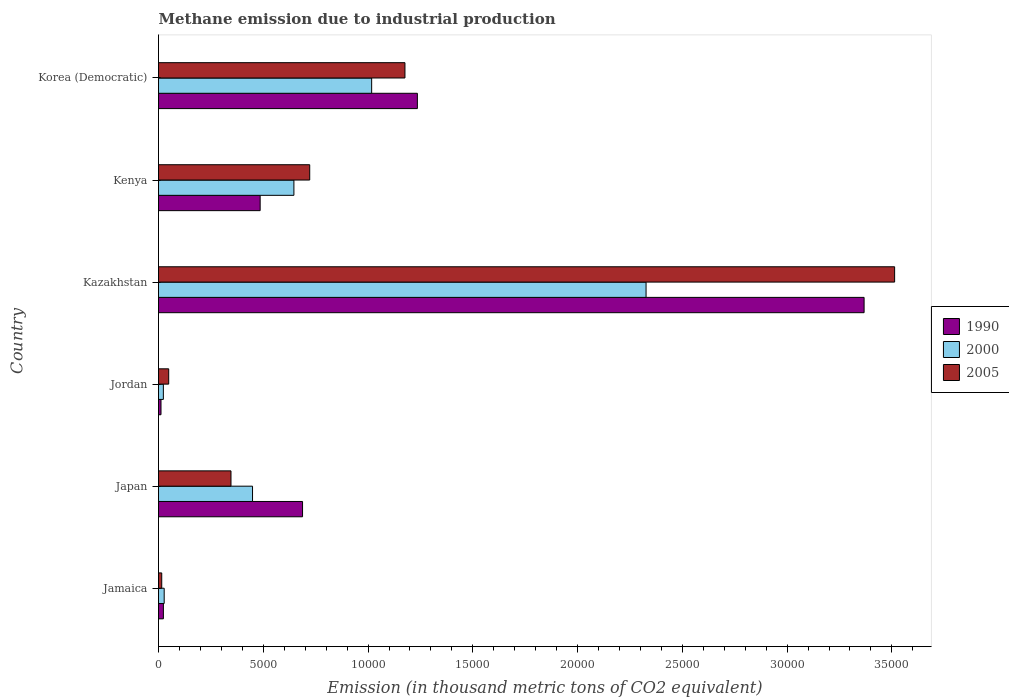How many different coloured bars are there?
Keep it short and to the point. 3. How many groups of bars are there?
Offer a very short reply. 6. Are the number of bars per tick equal to the number of legend labels?
Ensure brevity in your answer.  Yes. How many bars are there on the 3rd tick from the top?
Make the answer very short. 3. What is the label of the 4th group of bars from the top?
Provide a short and direct response. Jordan. What is the amount of methane emitted in 2005 in Kazakhstan?
Offer a very short reply. 3.51e+04. Across all countries, what is the maximum amount of methane emitted in 2005?
Make the answer very short. 3.51e+04. Across all countries, what is the minimum amount of methane emitted in 2000?
Give a very brief answer. 231.4. In which country was the amount of methane emitted in 2000 maximum?
Your answer should be compact. Kazakhstan. In which country was the amount of methane emitted in 1990 minimum?
Offer a terse response. Jordan. What is the total amount of methane emitted in 2005 in the graph?
Offer a terse response. 5.82e+04. What is the difference between the amount of methane emitted in 1990 in Jordan and that in Korea (Democratic)?
Provide a short and direct response. -1.22e+04. What is the difference between the amount of methane emitted in 2005 in Jordan and the amount of methane emitted in 2000 in Kenya?
Ensure brevity in your answer.  -5975.1. What is the average amount of methane emitted in 2000 per country?
Give a very brief answer. 7481.55. What is the difference between the amount of methane emitted in 2005 and amount of methane emitted in 2000 in Korea (Democratic)?
Your answer should be compact. 1589.4. In how many countries, is the amount of methane emitted in 2005 greater than 17000 thousand metric tons?
Offer a terse response. 1. What is the ratio of the amount of methane emitted in 2005 in Jamaica to that in Japan?
Provide a short and direct response. 0.04. Is the amount of methane emitted in 1990 in Japan less than that in Jordan?
Provide a succinct answer. No. Is the difference between the amount of methane emitted in 2005 in Kenya and Korea (Democratic) greater than the difference between the amount of methane emitted in 2000 in Kenya and Korea (Democratic)?
Offer a very short reply. No. What is the difference between the highest and the second highest amount of methane emitted in 1990?
Ensure brevity in your answer.  2.13e+04. What is the difference between the highest and the lowest amount of methane emitted in 2005?
Provide a short and direct response. 3.50e+04. What does the 1st bar from the top in Kazakhstan represents?
Keep it short and to the point. 2005. Is it the case that in every country, the sum of the amount of methane emitted in 2000 and amount of methane emitted in 1990 is greater than the amount of methane emitted in 2005?
Give a very brief answer. No. Are all the bars in the graph horizontal?
Offer a very short reply. Yes. What is the difference between two consecutive major ticks on the X-axis?
Make the answer very short. 5000. Are the values on the major ticks of X-axis written in scientific E-notation?
Offer a very short reply. No. Does the graph contain any zero values?
Provide a short and direct response. No. Where does the legend appear in the graph?
Make the answer very short. Center right. How many legend labels are there?
Your response must be concise. 3. What is the title of the graph?
Keep it short and to the point. Methane emission due to industrial production. What is the label or title of the X-axis?
Your response must be concise. Emission (in thousand metric tons of CO2 equivalent). What is the Emission (in thousand metric tons of CO2 equivalent) of 1990 in Jamaica?
Provide a short and direct response. 232.7. What is the Emission (in thousand metric tons of CO2 equivalent) in 2000 in Jamaica?
Offer a terse response. 270.4. What is the Emission (in thousand metric tons of CO2 equivalent) of 2005 in Jamaica?
Your response must be concise. 153.3. What is the Emission (in thousand metric tons of CO2 equivalent) of 1990 in Japan?
Your answer should be very brief. 6873.6. What is the Emission (in thousand metric tons of CO2 equivalent) in 2000 in Japan?
Provide a succinct answer. 4486.9. What is the Emission (in thousand metric tons of CO2 equivalent) of 2005 in Japan?
Keep it short and to the point. 3458.3. What is the Emission (in thousand metric tons of CO2 equivalent) in 1990 in Jordan?
Give a very brief answer. 118.4. What is the Emission (in thousand metric tons of CO2 equivalent) of 2000 in Jordan?
Your answer should be compact. 231.4. What is the Emission (in thousand metric tons of CO2 equivalent) in 2005 in Jordan?
Offer a terse response. 486.3. What is the Emission (in thousand metric tons of CO2 equivalent) in 1990 in Kazakhstan?
Provide a succinct answer. 3.37e+04. What is the Emission (in thousand metric tons of CO2 equivalent) in 2000 in Kazakhstan?
Your response must be concise. 2.33e+04. What is the Emission (in thousand metric tons of CO2 equivalent) of 2005 in Kazakhstan?
Provide a succinct answer. 3.51e+04. What is the Emission (in thousand metric tons of CO2 equivalent) in 1990 in Kenya?
Your answer should be compact. 4850.8. What is the Emission (in thousand metric tons of CO2 equivalent) of 2000 in Kenya?
Make the answer very short. 6461.4. What is the Emission (in thousand metric tons of CO2 equivalent) of 2005 in Kenya?
Your answer should be compact. 7215.9. What is the Emission (in thousand metric tons of CO2 equivalent) of 1990 in Korea (Democratic)?
Keep it short and to the point. 1.24e+04. What is the Emission (in thousand metric tons of CO2 equivalent) of 2000 in Korea (Democratic)?
Your answer should be compact. 1.02e+04. What is the Emission (in thousand metric tons of CO2 equivalent) of 2005 in Korea (Democratic)?
Give a very brief answer. 1.18e+04. Across all countries, what is the maximum Emission (in thousand metric tons of CO2 equivalent) of 1990?
Offer a terse response. 3.37e+04. Across all countries, what is the maximum Emission (in thousand metric tons of CO2 equivalent) of 2000?
Make the answer very short. 2.33e+04. Across all countries, what is the maximum Emission (in thousand metric tons of CO2 equivalent) in 2005?
Provide a succinct answer. 3.51e+04. Across all countries, what is the minimum Emission (in thousand metric tons of CO2 equivalent) of 1990?
Provide a short and direct response. 118.4. Across all countries, what is the minimum Emission (in thousand metric tons of CO2 equivalent) in 2000?
Give a very brief answer. 231.4. Across all countries, what is the minimum Emission (in thousand metric tons of CO2 equivalent) of 2005?
Keep it short and to the point. 153.3. What is the total Emission (in thousand metric tons of CO2 equivalent) in 1990 in the graph?
Your answer should be compact. 5.81e+04. What is the total Emission (in thousand metric tons of CO2 equivalent) in 2000 in the graph?
Your response must be concise. 4.49e+04. What is the total Emission (in thousand metric tons of CO2 equivalent) of 2005 in the graph?
Provide a short and direct response. 5.82e+04. What is the difference between the Emission (in thousand metric tons of CO2 equivalent) in 1990 in Jamaica and that in Japan?
Ensure brevity in your answer.  -6640.9. What is the difference between the Emission (in thousand metric tons of CO2 equivalent) in 2000 in Jamaica and that in Japan?
Your answer should be compact. -4216.5. What is the difference between the Emission (in thousand metric tons of CO2 equivalent) of 2005 in Jamaica and that in Japan?
Your answer should be compact. -3305. What is the difference between the Emission (in thousand metric tons of CO2 equivalent) of 1990 in Jamaica and that in Jordan?
Your answer should be compact. 114.3. What is the difference between the Emission (in thousand metric tons of CO2 equivalent) of 2000 in Jamaica and that in Jordan?
Your response must be concise. 39. What is the difference between the Emission (in thousand metric tons of CO2 equivalent) of 2005 in Jamaica and that in Jordan?
Offer a very short reply. -333. What is the difference between the Emission (in thousand metric tons of CO2 equivalent) in 1990 in Jamaica and that in Kazakhstan?
Provide a succinct answer. -3.34e+04. What is the difference between the Emission (in thousand metric tons of CO2 equivalent) in 2000 in Jamaica and that in Kazakhstan?
Give a very brief answer. -2.30e+04. What is the difference between the Emission (in thousand metric tons of CO2 equivalent) in 2005 in Jamaica and that in Kazakhstan?
Provide a succinct answer. -3.50e+04. What is the difference between the Emission (in thousand metric tons of CO2 equivalent) in 1990 in Jamaica and that in Kenya?
Give a very brief answer. -4618.1. What is the difference between the Emission (in thousand metric tons of CO2 equivalent) of 2000 in Jamaica and that in Kenya?
Give a very brief answer. -6191. What is the difference between the Emission (in thousand metric tons of CO2 equivalent) in 2005 in Jamaica and that in Kenya?
Ensure brevity in your answer.  -7062.6. What is the difference between the Emission (in thousand metric tons of CO2 equivalent) in 1990 in Jamaica and that in Korea (Democratic)?
Offer a very short reply. -1.21e+04. What is the difference between the Emission (in thousand metric tons of CO2 equivalent) in 2000 in Jamaica and that in Korea (Democratic)?
Provide a succinct answer. -9901.2. What is the difference between the Emission (in thousand metric tons of CO2 equivalent) in 2005 in Jamaica and that in Korea (Democratic)?
Your answer should be very brief. -1.16e+04. What is the difference between the Emission (in thousand metric tons of CO2 equivalent) in 1990 in Japan and that in Jordan?
Keep it short and to the point. 6755.2. What is the difference between the Emission (in thousand metric tons of CO2 equivalent) in 2000 in Japan and that in Jordan?
Keep it short and to the point. 4255.5. What is the difference between the Emission (in thousand metric tons of CO2 equivalent) of 2005 in Japan and that in Jordan?
Offer a very short reply. 2972. What is the difference between the Emission (in thousand metric tons of CO2 equivalent) in 1990 in Japan and that in Kazakhstan?
Your response must be concise. -2.68e+04. What is the difference between the Emission (in thousand metric tons of CO2 equivalent) in 2000 in Japan and that in Kazakhstan?
Make the answer very short. -1.88e+04. What is the difference between the Emission (in thousand metric tons of CO2 equivalent) of 2005 in Japan and that in Kazakhstan?
Your answer should be very brief. -3.17e+04. What is the difference between the Emission (in thousand metric tons of CO2 equivalent) of 1990 in Japan and that in Kenya?
Keep it short and to the point. 2022.8. What is the difference between the Emission (in thousand metric tons of CO2 equivalent) in 2000 in Japan and that in Kenya?
Ensure brevity in your answer.  -1974.5. What is the difference between the Emission (in thousand metric tons of CO2 equivalent) in 2005 in Japan and that in Kenya?
Give a very brief answer. -3757.6. What is the difference between the Emission (in thousand metric tons of CO2 equivalent) of 1990 in Japan and that in Korea (Democratic)?
Provide a succinct answer. -5480.1. What is the difference between the Emission (in thousand metric tons of CO2 equivalent) in 2000 in Japan and that in Korea (Democratic)?
Provide a short and direct response. -5684.7. What is the difference between the Emission (in thousand metric tons of CO2 equivalent) of 2005 in Japan and that in Korea (Democratic)?
Ensure brevity in your answer.  -8302.7. What is the difference between the Emission (in thousand metric tons of CO2 equivalent) in 1990 in Jordan and that in Kazakhstan?
Offer a very short reply. -3.36e+04. What is the difference between the Emission (in thousand metric tons of CO2 equivalent) of 2000 in Jordan and that in Kazakhstan?
Ensure brevity in your answer.  -2.30e+04. What is the difference between the Emission (in thousand metric tons of CO2 equivalent) of 2005 in Jordan and that in Kazakhstan?
Keep it short and to the point. -3.46e+04. What is the difference between the Emission (in thousand metric tons of CO2 equivalent) of 1990 in Jordan and that in Kenya?
Keep it short and to the point. -4732.4. What is the difference between the Emission (in thousand metric tons of CO2 equivalent) of 2000 in Jordan and that in Kenya?
Keep it short and to the point. -6230. What is the difference between the Emission (in thousand metric tons of CO2 equivalent) of 2005 in Jordan and that in Kenya?
Offer a terse response. -6729.6. What is the difference between the Emission (in thousand metric tons of CO2 equivalent) of 1990 in Jordan and that in Korea (Democratic)?
Offer a terse response. -1.22e+04. What is the difference between the Emission (in thousand metric tons of CO2 equivalent) of 2000 in Jordan and that in Korea (Democratic)?
Your answer should be very brief. -9940.2. What is the difference between the Emission (in thousand metric tons of CO2 equivalent) of 2005 in Jordan and that in Korea (Democratic)?
Your response must be concise. -1.13e+04. What is the difference between the Emission (in thousand metric tons of CO2 equivalent) in 1990 in Kazakhstan and that in Kenya?
Provide a short and direct response. 2.88e+04. What is the difference between the Emission (in thousand metric tons of CO2 equivalent) in 2000 in Kazakhstan and that in Kenya?
Offer a terse response. 1.68e+04. What is the difference between the Emission (in thousand metric tons of CO2 equivalent) in 2005 in Kazakhstan and that in Kenya?
Give a very brief answer. 2.79e+04. What is the difference between the Emission (in thousand metric tons of CO2 equivalent) of 1990 in Kazakhstan and that in Korea (Democratic)?
Keep it short and to the point. 2.13e+04. What is the difference between the Emission (in thousand metric tons of CO2 equivalent) of 2000 in Kazakhstan and that in Korea (Democratic)?
Give a very brief answer. 1.31e+04. What is the difference between the Emission (in thousand metric tons of CO2 equivalent) in 2005 in Kazakhstan and that in Korea (Democratic)?
Keep it short and to the point. 2.34e+04. What is the difference between the Emission (in thousand metric tons of CO2 equivalent) in 1990 in Kenya and that in Korea (Democratic)?
Ensure brevity in your answer.  -7502.9. What is the difference between the Emission (in thousand metric tons of CO2 equivalent) in 2000 in Kenya and that in Korea (Democratic)?
Offer a very short reply. -3710.2. What is the difference between the Emission (in thousand metric tons of CO2 equivalent) in 2005 in Kenya and that in Korea (Democratic)?
Your answer should be compact. -4545.1. What is the difference between the Emission (in thousand metric tons of CO2 equivalent) in 1990 in Jamaica and the Emission (in thousand metric tons of CO2 equivalent) in 2000 in Japan?
Provide a short and direct response. -4254.2. What is the difference between the Emission (in thousand metric tons of CO2 equivalent) of 1990 in Jamaica and the Emission (in thousand metric tons of CO2 equivalent) of 2005 in Japan?
Ensure brevity in your answer.  -3225.6. What is the difference between the Emission (in thousand metric tons of CO2 equivalent) in 2000 in Jamaica and the Emission (in thousand metric tons of CO2 equivalent) in 2005 in Japan?
Provide a short and direct response. -3187.9. What is the difference between the Emission (in thousand metric tons of CO2 equivalent) in 1990 in Jamaica and the Emission (in thousand metric tons of CO2 equivalent) in 2000 in Jordan?
Your answer should be compact. 1.3. What is the difference between the Emission (in thousand metric tons of CO2 equivalent) of 1990 in Jamaica and the Emission (in thousand metric tons of CO2 equivalent) of 2005 in Jordan?
Offer a terse response. -253.6. What is the difference between the Emission (in thousand metric tons of CO2 equivalent) in 2000 in Jamaica and the Emission (in thousand metric tons of CO2 equivalent) in 2005 in Jordan?
Provide a succinct answer. -215.9. What is the difference between the Emission (in thousand metric tons of CO2 equivalent) of 1990 in Jamaica and the Emission (in thousand metric tons of CO2 equivalent) of 2000 in Kazakhstan?
Make the answer very short. -2.30e+04. What is the difference between the Emission (in thousand metric tons of CO2 equivalent) in 1990 in Jamaica and the Emission (in thousand metric tons of CO2 equivalent) in 2005 in Kazakhstan?
Your answer should be compact. -3.49e+04. What is the difference between the Emission (in thousand metric tons of CO2 equivalent) of 2000 in Jamaica and the Emission (in thousand metric tons of CO2 equivalent) of 2005 in Kazakhstan?
Your answer should be compact. -3.49e+04. What is the difference between the Emission (in thousand metric tons of CO2 equivalent) of 1990 in Jamaica and the Emission (in thousand metric tons of CO2 equivalent) of 2000 in Kenya?
Make the answer very short. -6228.7. What is the difference between the Emission (in thousand metric tons of CO2 equivalent) in 1990 in Jamaica and the Emission (in thousand metric tons of CO2 equivalent) in 2005 in Kenya?
Your answer should be compact. -6983.2. What is the difference between the Emission (in thousand metric tons of CO2 equivalent) in 2000 in Jamaica and the Emission (in thousand metric tons of CO2 equivalent) in 2005 in Kenya?
Provide a succinct answer. -6945.5. What is the difference between the Emission (in thousand metric tons of CO2 equivalent) of 1990 in Jamaica and the Emission (in thousand metric tons of CO2 equivalent) of 2000 in Korea (Democratic)?
Give a very brief answer. -9938.9. What is the difference between the Emission (in thousand metric tons of CO2 equivalent) of 1990 in Jamaica and the Emission (in thousand metric tons of CO2 equivalent) of 2005 in Korea (Democratic)?
Keep it short and to the point. -1.15e+04. What is the difference between the Emission (in thousand metric tons of CO2 equivalent) in 2000 in Jamaica and the Emission (in thousand metric tons of CO2 equivalent) in 2005 in Korea (Democratic)?
Ensure brevity in your answer.  -1.15e+04. What is the difference between the Emission (in thousand metric tons of CO2 equivalent) of 1990 in Japan and the Emission (in thousand metric tons of CO2 equivalent) of 2000 in Jordan?
Provide a succinct answer. 6642.2. What is the difference between the Emission (in thousand metric tons of CO2 equivalent) in 1990 in Japan and the Emission (in thousand metric tons of CO2 equivalent) in 2005 in Jordan?
Offer a terse response. 6387.3. What is the difference between the Emission (in thousand metric tons of CO2 equivalent) in 2000 in Japan and the Emission (in thousand metric tons of CO2 equivalent) in 2005 in Jordan?
Offer a terse response. 4000.6. What is the difference between the Emission (in thousand metric tons of CO2 equivalent) in 1990 in Japan and the Emission (in thousand metric tons of CO2 equivalent) in 2000 in Kazakhstan?
Your answer should be compact. -1.64e+04. What is the difference between the Emission (in thousand metric tons of CO2 equivalent) in 1990 in Japan and the Emission (in thousand metric tons of CO2 equivalent) in 2005 in Kazakhstan?
Make the answer very short. -2.83e+04. What is the difference between the Emission (in thousand metric tons of CO2 equivalent) in 2000 in Japan and the Emission (in thousand metric tons of CO2 equivalent) in 2005 in Kazakhstan?
Your answer should be compact. -3.06e+04. What is the difference between the Emission (in thousand metric tons of CO2 equivalent) in 1990 in Japan and the Emission (in thousand metric tons of CO2 equivalent) in 2000 in Kenya?
Ensure brevity in your answer.  412.2. What is the difference between the Emission (in thousand metric tons of CO2 equivalent) in 1990 in Japan and the Emission (in thousand metric tons of CO2 equivalent) in 2005 in Kenya?
Your response must be concise. -342.3. What is the difference between the Emission (in thousand metric tons of CO2 equivalent) in 2000 in Japan and the Emission (in thousand metric tons of CO2 equivalent) in 2005 in Kenya?
Give a very brief answer. -2729. What is the difference between the Emission (in thousand metric tons of CO2 equivalent) in 1990 in Japan and the Emission (in thousand metric tons of CO2 equivalent) in 2000 in Korea (Democratic)?
Offer a very short reply. -3298. What is the difference between the Emission (in thousand metric tons of CO2 equivalent) of 1990 in Japan and the Emission (in thousand metric tons of CO2 equivalent) of 2005 in Korea (Democratic)?
Offer a terse response. -4887.4. What is the difference between the Emission (in thousand metric tons of CO2 equivalent) of 2000 in Japan and the Emission (in thousand metric tons of CO2 equivalent) of 2005 in Korea (Democratic)?
Keep it short and to the point. -7274.1. What is the difference between the Emission (in thousand metric tons of CO2 equivalent) of 1990 in Jordan and the Emission (in thousand metric tons of CO2 equivalent) of 2000 in Kazakhstan?
Provide a short and direct response. -2.31e+04. What is the difference between the Emission (in thousand metric tons of CO2 equivalent) in 1990 in Jordan and the Emission (in thousand metric tons of CO2 equivalent) in 2005 in Kazakhstan?
Give a very brief answer. -3.50e+04. What is the difference between the Emission (in thousand metric tons of CO2 equivalent) in 2000 in Jordan and the Emission (in thousand metric tons of CO2 equivalent) in 2005 in Kazakhstan?
Your response must be concise. -3.49e+04. What is the difference between the Emission (in thousand metric tons of CO2 equivalent) of 1990 in Jordan and the Emission (in thousand metric tons of CO2 equivalent) of 2000 in Kenya?
Your answer should be very brief. -6343. What is the difference between the Emission (in thousand metric tons of CO2 equivalent) of 1990 in Jordan and the Emission (in thousand metric tons of CO2 equivalent) of 2005 in Kenya?
Keep it short and to the point. -7097.5. What is the difference between the Emission (in thousand metric tons of CO2 equivalent) of 2000 in Jordan and the Emission (in thousand metric tons of CO2 equivalent) of 2005 in Kenya?
Your answer should be compact. -6984.5. What is the difference between the Emission (in thousand metric tons of CO2 equivalent) of 1990 in Jordan and the Emission (in thousand metric tons of CO2 equivalent) of 2000 in Korea (Democratic)?
Keep it short and to the point. -1.01e+04. What is the difference between the Emission (in thousand metric tons of CO2 equivalent) in 1990 in Jordan and the Emission (in thousand metric tons of CO2 equivalent) in 2005 in Korea (Democratic)?
Give a very brief answer. -1.16e+04. What is the difference between the Emission (in thousand metric tons of CO2 equivalent) in 2000 in Jordan and the Emission (in thousand metric tons of CO2 equivalent) in 2005 in Korea (Democratic)?
Ensure brevity in your answer.  -1.15e+04. What is the difference between the Emission (in thousand metric tons of CO2 equivalent) in 1990 in Kazakhstan and the Emission (in thousand metric tons of CO2 equivalent) in 2000 in Kenya?
Give a very brief answer. 2.72e+04. What is the difference between the Emission (in thousand metric tons of CO2 equivalent) of 1990 in Kazakhstan and the Emission (in thousand metric tons of CO2 equivalent) of 2005 in Kenya?
Provide a succinct answer. 2.65e+04. What is the difference between the Emission (in thousand metric tons of CO2 equivalent) in 2000 in Kazakhstan and the Emission (in thousand metric tons of CO2 equivalent) in 2005 in Kenya?
Your answer should be very brief. 1.61e+04. What is the difference between the Emission (in thousand metric tons of CO2 equivalent) of 1990 in Kazakhstan and the Emission (in thousand metric tons of CO2 equivalent) of 2000 in Korea (Democratic)?
Your response must be concise. 2.35e+04. What is the difference between the Emission (in thousand metric tons of CO2 equivalent) in 1990 in Kazakhstan and the Emission (in thousand metric tons of CO2 equivalent) in 2005 in Korea (Democratic)?
Your answer should be very brief. 2.19e+04. What is the difference between the Emission (in thousand metric tons of CO2 equivalent) of 2000 in Kazakhstan and the Emission (in thousand metric tons of CO2 equivalent) of 2005 in Korea (Democratic)?
Your response must be concise. 1.15e+04. What is the difference between the Emission (in thousand metric tons of CO2 equivalent) of 1990 in Kenya and the Emission (in thousand metric tons of CO2 equivalent) of 2000 in Korea (Democratic)?
Your answer should be very brief. -5320.8. What is the difference between the Emission (in thousand metric tons of CO2 equivalent) of 1990 in Kenya and the Emission (in thousand metric tons of CO2 equivalent) of 2005 in Korea (Democratic)?
Provide a short and direct response. -6910.2. What is the difference between the Emission (in thousand metric tons of CO2 equivalent) in 2000 in Kenya and the Emission (in thousand metric tons of CO2 equivalent) in 2005 in Korea (Democratic)?
Keep it short and to the point. -5299.6. What is the average Emission (in thousand metric tons of CO2 equivalent) of 1990 per country?
Keep it short and to the point. 9683.75. What is the average Emission (in thousand metric tons of CO2 equivalent) in 2000 per country?
Offer a terse response. 7481.55. What is the average Emission (in thousand metric tons of CO2 equivalent) of 2005 per country?
Your answer should be compact. 9700.82. What is the difference between the Emission (in thousand metric tons of CO2 equivalent) of 1990 and Emission (in thousand metric tons of CO2 equivalent) of 2000 in Jamaica?
Offer a very short reply. -37.7. What is the difference between the Emission (in thousand metric tons of CO2 equivalent) in 1990 and Emission (in thousand metric tons of CO2 equivalent) in 2005 in Jamaica?
Give a very brief answer. 79.4. What is the difference between the Emission (in thousand metric tons of CO2 equivalent) in 2000 and Emission (in thousand metric tons of CO2 equivalent) in 2005 in Jamaica?
Your response must be concise. 117.1. What is the difference between the Emission (in thousand metric tons of CO2 equivalent) of 1990 and Emission (in thousand metric tons of CO2 equivalent) of 2000 in Japan?
Give a very brief answer. 2386.7. What is the difference between the Emission (in thousand metric tons of CO2 equivalent) of 1990 and Emission (in thousand metric tons of CO2 equivalent) of 2005 in Japan?
Give a very brief answer. 3415.3. What is the difference between the Emission (in thousand metric tons of CO2 equivalent) in 2000 and Emission (in thousand metric tons of CO2 equivalent) in 2005 in Japan?
Keep it short and to the point. 1028.6. What is the difference between the Emission (in thousand metric tons of CO2 equivalent) in 1990 and Emission (in thousand metric tons of CO2 equivalent) in 2000 in Jordan?
Your response must be concise. -113. What is the difference between the Emission (in thousand metric tons of CO2 equivalent) of 1990 and Emission (in thousand metric tons of CO2 equivalent) of 2005 in Jordan?
Give a very brief answer. -367.9. What is the difference between the Emission (in thousand metric tons of CO2 equivalent) in 2000 and Emission (in thousand metric tons of CO2 equivalent) in 2005 in Jordan?
Provide a succinct answer. -254.9. What is the difference between the Emission (in thousand metric tons of CO2 equivalent) of 1990 and Emission (in thousand metric tons of CO2 equivalent) of 2000 in Kazakhstan?
Ensure brevity in your answer.  1.04e+04. What is the difference between the Emission (in thousand metric tons of CO2 equivalent) of 1990 and Emission (in thousand metric tons of CO2 equivalent) of 2005 in Kazakhstan?
Provide a succinct answer. -1456.8. What is the difference between the Emission (in thousand metric tons of CO2 equivalent) in 2000 and Emission (in thousand metric tons of CO2 equivalent) in 2005 in Kazakhstan?
Provide a succinct answer. -1.19e+04. What is the difference between the Emission (in thousand metric tons of CO2 equivalent) in 1990 and Emission (in thousand metric tons of CO2 equivalent) in 2000 in Kenya?
Provide a short and direct response. -1610.6. What is the difference between the Emission (in thousand metric tons of CO2 equivalent) in 1990 and Emission (in thousand metric tons of CO2 equivalent) in 2005 in Kenya?
Your answer should be compact. -2365.1. What is the difference between the Emission (in thousand metric tons of CO2 equivalent) of 2000 and Emission (in thousand metric tons of CO2 equivalent) of 2005 in Kenya?
Your response must be concise. -754.5. What is the difference between the Emission (in thousand metric tons of CO2 equivalent) in 1990 and Emission (in thousand metric tons of CO2 equivalent) in 2000 in Korea (Democratic)?
Your response must be concise. 2182.1. What is the difference between the Emission (in thousand metric tons of CO2 equivalent) of 1990 and Emission (in thousand metric tons of CO2 equivalent) of 2005 in Korea (Democratic)?
Your answer should be very brief. 592.7. What is the difference between the Emission (in thousand metric tons of CO2 equivalent) of 2000 and Emission (in thousand metric tons of CO2 equivalent) of 2005 in Korea (Democratic)?
Make the answer very short. -1589.4. What is the ratio of the Emission (in thousand metric tons of CO2 equivalent) in 1990 in Jamaica to that in Japan?
Make the answer very short. 0.03. What is the ratio of the Emission (in thousand metric tons of CO2 equivalent) in 2000 in Jamaica to that in Japan?
Your answer should be very brief. 0.06. What is the ratio of the Emission (in thousand metric tons of CO2 equivalent) of 2005 in Jamaica to that in Japan?
Offer a very short reply. 0.04. What is the ratio of the Emission (in thousand metric tons of CO2 equivalent) in 1990 in Jamaica to that in Jordan?
Your response must be concise. 1.97. What is the ratio of the Emission (in thousand metric tons of CO2 equivalent) of 2000 in Jamaica to that in Jordan?
Keep it short and to the point. 1.17. What is the ratio of the Emission (in thousand metric tons of CO2 equivalent) in 2005 in Jamaica to that in Jordan?
Provide a succinct answer. 0.32. What is the ratio of the Emission (in thousand metric tons of CO2 equivalent) in 1990 in Jamaica to that in Kazakhstan?
Your answer should be very brief. 0.01. What is the ratio of the Emission (in thousand metric tons of CO2 equivalent) of 2000 in Jamaica to that in Kazakhstan?
Your answer should be compact. 0.01. What is the ratio of the Emission (in thousand metric tons of CO2 equivalent) of 2005 in Jamaica to that in Kazakhstan?
Keep it short and to the point. 0. What is the ratio of the Emission (in thousand metric tons of CO2 equivalent) of 1990 in Jamaica to that in Kenya?
Provide a succinct answer. 0.05. What is the ratio of the Emission (in thousand metric tons of CO2 equivalent) in 2000 in Jamaica to that in Kenya?
Offer a terse response. 0.04. What is the ratio of the Emission (in thousand metric tons of CO2 equivalent) of 2005 in Jamaica to that in Kenya?
Offer a very short reply. 0.02. What is the ratio of the Emission (in thousand metric tons of CO2 equivalent) in 1990 in Jamaica to that in Korea (Democratic)?
Provide a short and direct response. 0.02. What is the ratio of the Emission (in thousand metric tons of CO2 equivalent) of 2000 in Jamaica to that in Korea (Democratic)?
Offer a very short reply. 0.03. What is the ratio of the Emission (in thousand metric tons of CO2 equivalent) of 2005 in Jamaica to that in Korea (Democratic)?
Provide a succinct answer. 0.01. What is the ratio of the Emission (in thousand metric tons of CO2 equivalent) of 1990 in Japan to that in Jordan?
Your response must be concise. 58.05. What is the ratio of the Emission (in thousand metric tons of CO2 equivalent) in 2000 in Japan to that in Jordan?
Your answer should be compact. 19.39. What is the ratio of the Emission (in thousand metric tons of CO2 equivalent) of 2005 in Japan to that in Jordan?
Provide a short and direct response. 7.11. What is the ratio of the Emission (in thousand metric tons of CO2 equivalent) in 1990 in Japan to that in Kazakhstan?
Offer a terse response. 0.2. What is the ratio of the Emission (in thousand metric tons of CO2 equivalent) in 2000 in Japan to that in Kazakhstan?
Keep it short and to the point. 0.19. What is the ratio of the Emission (in thousand metric tons of CO2 equivalent) in 2005 in Japan to that in Kazakhstan?
Provide a succinct answer. 0.1. What is the ratio of the Emission (in thousand metric tons of CO2 equivalent) of 1990 in Japan to that in Kenya?
Give a very brief answer. 1.42. What is the ratio of the Emission (in thousand metric tons of CO2 equivalent) of 2000 in Japan to that in Kenya?
Your answer should be compact. 0.69. What is the ratio of the Emission (in thousand metric tons of CO2 equivalent) in 2005 in Japan to that in Kenya?
Ensure brevity in your answer.  0.48. What is the ratio of the Emission (in thousand metric tons of CO2 equivalent) of 1990 in Japan to that in Korea (Democratic)?
Give a very brief answer. 0.56. What is the ratio of the Emission (in thousand metric tons of CO2 equivalent) in 2000 in Japan to that in Korea (Democratic)?
Give a very brief answer. 0.44. What is the ratio of the Emission (in thousand metric tons of CO2 equivalent) in 2005 in Japan to that in Korea (Democratic)?
Ensure brevity in your answer.  0.29. What is the ratio of the Emission (in thousand metric tons of CO2 equivalent) in 1990 in Jordan to that in Kazakhstan?
Offer a very short reply. 0. What is the ratio of the Emission (in thousand metric tons of CO2 equivalent) in 2000 in Jordan to that in Kazakhstan?
Provide a succinct answer. 0.01. What is the ratio of the Emission (in thousand metric tons of CO2 equivalent) of 2005 in Jordan to that in Kazakhstan?
Offer a terse response. 0.01. What is the ratio of the Emission (in thousand metric tons of CO2 equivalent) in 1990 in Jordan to that in Kenya?
Make the answer very short. 0.02. What is the ratio of the Emission (in thousand metric tons of CO2 equivalent) of 2000 in Jordan to that in Kenya?
Your answer should be very brief. 0.04. What is the ratio of the Emission (in thousand metric tons of CO2 equivalent) of 2005 in Jordan to that in Kenya?
Offer a terse response. 0.07. What is the ratio of the Emission (in thousand metric tons of CO2 equivalent) in 1990 in Jordan to that in Korea (Democratic)?
Offer a very short reply. 0.01. What is the ratio of the Emission (in thousand metric tons of CO2 equivalent) of 2000 in Jordan to that in Korea (Democratic)?
Provide a succinct answer. 0.02. What is the ratio of the Emission (in thousand metric tons of CO2 equivalent) in 2005 in Jordan to that in Korea (Democratic)?
Give a very brief answer. 0.04. What is the ratio of the Emission (in thousand metric tons of CO2 equivalent) in 1990 in Kazakhstan to that in Kenya?
Keep it short and to the point. 6.94. What is the ratio of the Emission (in thousand metric tons of CO2 equivalent) in 2000 in Kazakhstan to that in Kenya?
Ensure brevity in your answer.  3.6. What is the ratio of the Emission (in thousand metric tons of CO2 equivalent) in 2005 in Kazakhstan to that in Kenya?
Offer a terse response. 4.87. What is the ratio of the Emission (in thousand metric tons of CO2 equivalent) of 1990 in Kazakhstan to that in Korea (Democratic)?
Your response must be concise. 2.73. What is the ratio of the Emission (in thousand metric tons of CO2 equivalent) in 2000 in Kazakhstan to that in Korea (Democratic)?
Make the answer very short. 2.29. What is the ratio of the Emission (in thousand metric tons of CO2 equivalent) in 2005 in Kazakhstan to that in Korea (Democratic)?
Keep it short and to the point. 2.99. What is the ratio of the Emission (in thousand metric tons of CO2 equivalent) in 1990 in Kenya to that in Korea (Democratic)?
Make the answer very short. 0.39. What is the ratio of the Emission (in thousand metric tons of CO2 equivalent) in 2000 in Kenya to that in Korea (Democratic)?
Provide a short and direct response. 0.64. What is the ratio of the Emission (in thousand metric tons of CO2 equivalent) in 2005 in Kenya to that in Korea (Democratic)?
Your response must be concise. 0.61. What is the difference between the highest and the second highest Emission (in thousand metric tons of CO2 equivalent) in 1990?
Provide a succinct answer. 2.13e+04. What is the difference between the highest and the second highest Emission (in thousand metric tons of CO2 equivalent) in 2000?
Make the answer very short. 1.31e+04. What is the difference between the highest and the second highest Emission (in thousand metric tons of CO2 equivalent) in 2005?
Your response must be concise. 2.34e+04. What is the difference between the highest and the lowest Emission (in thousand metric tons of CO2 equivalent) in 1990?
Give a very brief answer. 3.36e+04. What is the difference between the highest and the lowest Emission (in thousand metric tons of CO2 equivalent) of 2000?
Your answer should be very brief. 2.30e+04. What is the difference between the highest and the lowest Emission (in thousand metric tons of CO2 equivalent) of 2005?
Provide a short and direct response. 3.50e+04. 